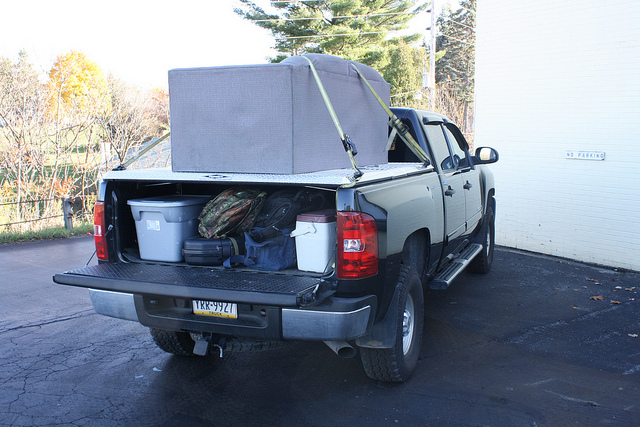Read and extract the text from this image. TRR-9927 